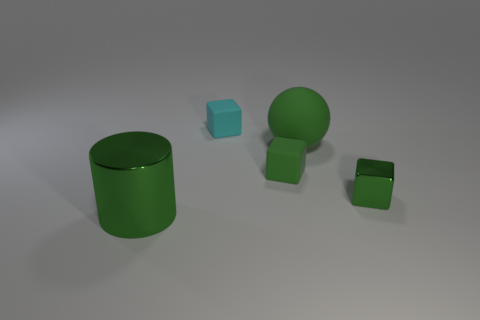Subtract all blue cylinders. How many green blocks are left? 2 Add 5 small green metallic spheres. How many objects exist? 10 Subtract 1 cubes. How many cubes are left? 2 Subtract all tiny green blocks. How many blocks are left? 1 Subtract all spheres. How many objects are left? 4 Subtract all tiny yellow metal spheres. Subtract all large balls. How many objects are left? 4 Add 4 green balls. How many green balls are left? 5 Add 4 cyan cubes. How many cyan cubes exist? 5 Subtract 0 red cylinders. How many objects are left? 5 